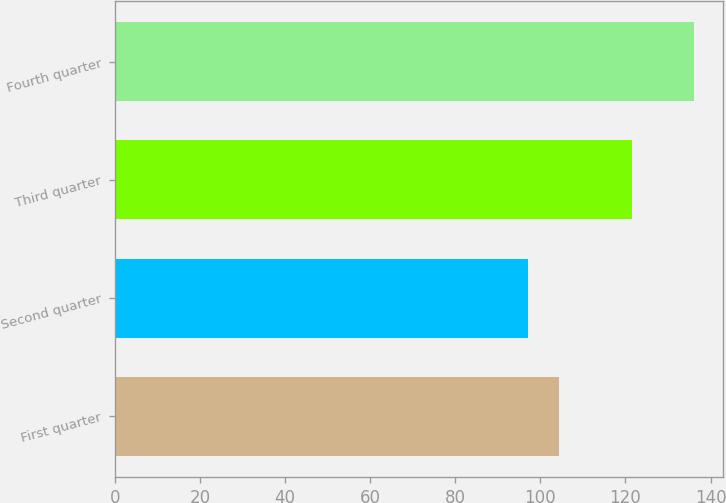<chart> <loc_0><loc_0><loc_500><loc_500><bar_chart><fcel>First quarter<fcel>Second quarter<fcel>Third quarter<fcel>Fourth quarter<nl><fcel>104.3<fcel>97.11<fcel>121.56<fcel>136.08<nl></chart> 